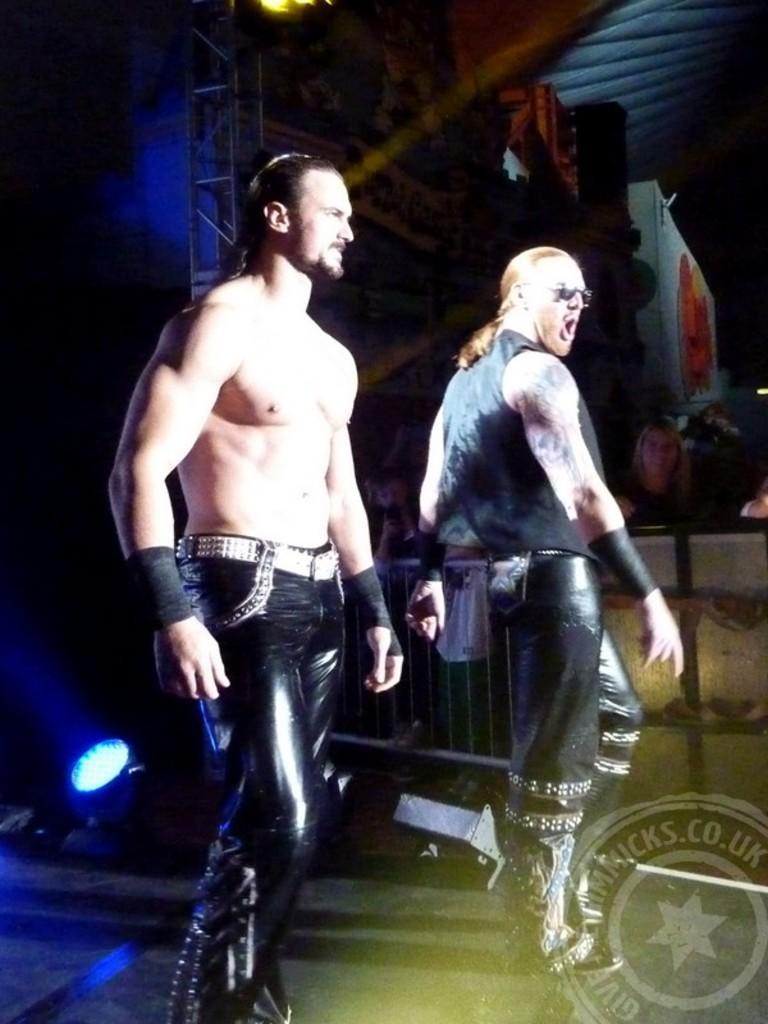How would you summarize this image in a sentence or two? In this image I can see two people are standing and wearing black dresses. Back I can see the light and dark background. 